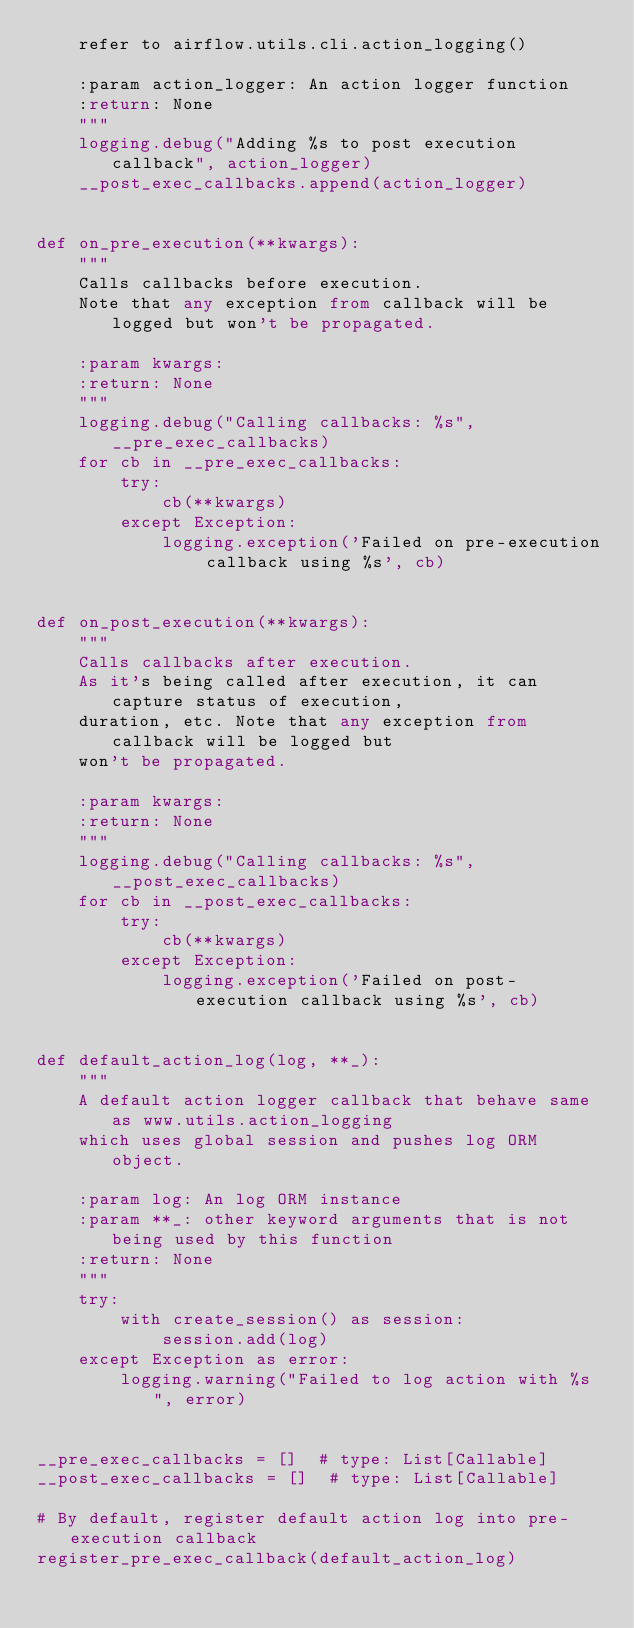<code> <loc_0><loc_0><loc_500><loc_500><_Python_>    refer to airflow.utils.cli.action_logging()

    :param action_logger: An action logger function
    :return: None
    """
    logging.debug("Adding %s to post execution callback", action_logger)
    __post_exec_callbacks.append(action_logger)


def on_pre_execution(**kwargs):
    """
    Calls callbacks before execution.
    Note that any exception from callback will be logged but won't be propagated.

    :param kwargs:
    :return: None
    """
    logging.debug("Calling callbacks: %s", __pre_exec_callbacks)
    for cb in __pre_exec_callbacks:
        try:
            cb(**kwargs)
        except Exception:
            logging.exception('Failed on pre-execution callback using %s', cb)


def on_post_execution(**kwargs):
    """
    Calls callbacks after execution.
    As it's being called after execution, it can capture status of execution,
    duration, etc. Note that any exception from callback will be logged but
    won't be propagated.

    :param kwargs:
    :return: None
    """
    logging.debug("Calling callbacks: %s", __post_exec_callbacks)
    for cb in __post_exec_callbacks:
        try:
            cb(**kwargs)
        except Exception:
            logging.exception('Failed on post-execution callback using %s', cb)


def default_action_log(log, **_):
    """
    A default action logger callback that behave same as www.utils.action_logging
    which uses global session and pushes log ORM object.

    :param log: An log ORM instance
    :param **_: other keyword arguments that is not being used by this function
    :return: None
    """
    try:
        with create_session() as session:
            session.add(log)
    except Exception as error:
        logging.warning("Failed to log action with %s", error)


__pre_exec_callbacks = []  # type: List[Callable]
__post_exec_callbacks = []  # type: List[Callable]

# By default, register default action log into pre-execution callback
register_pre_exec_callback(default_action_log)
</code> 